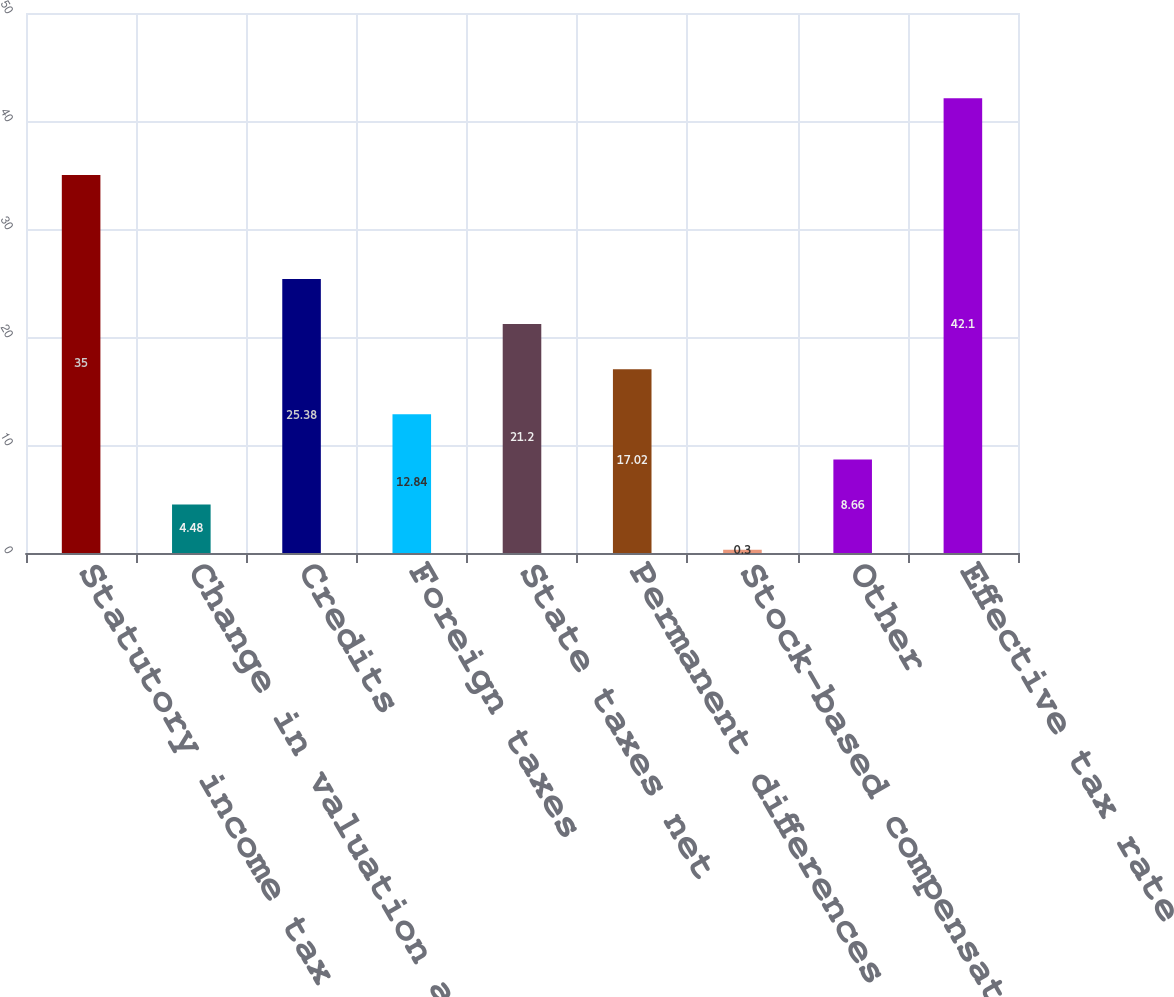<chart> <loc_0><loc_0><loc_500><loc_500><bar_chart><fcel>Statutory income tax rate<fcel>Change in valuation allowance<fcel>Credits<fcel>Foreign taxes<fcel>State taxes net<fcel>Permanent differences<fcel>Stock-based compensation<fcel>Other<fcel>Effective tax rate<nl><fcel>35<fcel>4.48<fcel>25.38<fcel>12.84<fcel>21.2<fcel>17.02<fcel>0.3<fcel>8.66<fcel>42.1<nl></chart> 